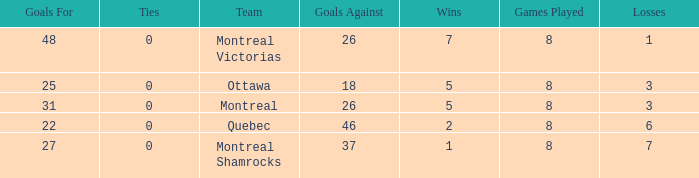How many losses did the team with 22 goals for andmore than 8 games played have? 0.0. 